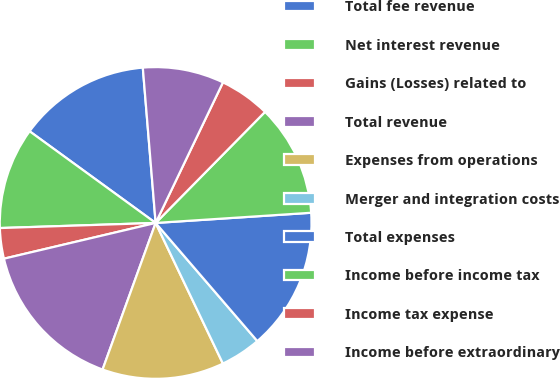Convert chart. <chart><loc_0><loc_0><loc_500><loc_500><pie_chart><fcel>Total fee revenue<fcel>Net interest revenue<fcel>Gains (Losses) related to<fcel>Total revenue<fcel>Expenses from operations<fcel>Merger and integration costs<fcel>Total expenses<fcel>Income before income tax<fcel>Income tax expense<fcel>Income before extraordinary<nl><fcel>13.68%<fcel>10.53%<fcel>3.16%<fcel>15.79%<fcel>12.63%<fcel>4.21%<fcel>14.73%<fcel>11.58%<fcel>5.27%<fcel>8.42%<nl></chart> 